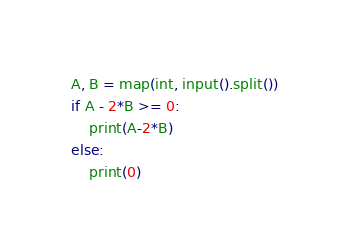<code> <loc_0><loc_0><loc_500><loc_500><_Python_>A, B = map(int, input().split())
if A - 2*B >= 0:
    print(A-2*B)
else:
    print(0)</code> 